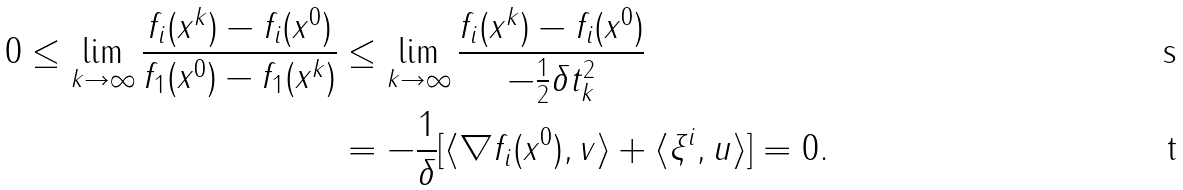Convert formula to latex. <formula><loc_0><loc_0><loc_500><loc_500>0 \leq \lim _ { k \to \infty } \frac { f _ { i } ( x ^ { k } ) - f _ { i } ( x ^ { 0 } ) } { f _ { 1 } ( x ^ { 0 } ) - f _ { 1 } ( x ^ { k } ) } & \leq \lim _ { k \to \infty } \frac { f _ { i } ( x ^ { k } ) - f _ { i } ( x ^ { 0 } ) } { - \frac { 1 } { 2 } \delta t ^ { 2 } _ { k } } \\ & = - \frac { 1 } { \delta } [ \langle \nabla f _ { i } ( x ^ { 0 } ) , v \rangle + \langle \xi ^ { i } , u \rangle ] = 0 .</formula> 